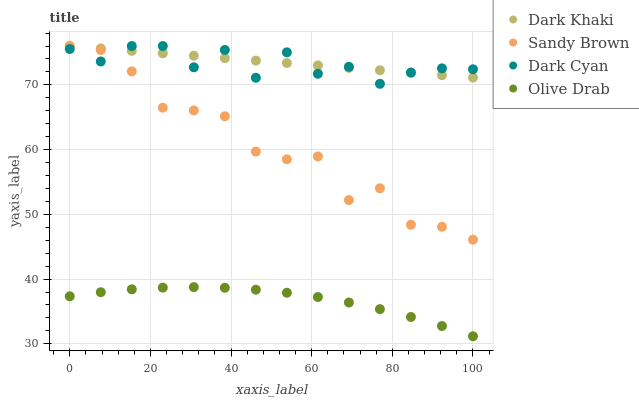Does Olive Drab have the minimum area under the curve?
Answer yes or no. Yes. Does Dark Khaki have the maximum area under the curve?
Answer yes or no. Yes. Does Dark Cyan have the minimum area under the curve?
Answer yes or no. No. Does Dark Cyan have the maximum area under the curve?
Answer yes or no. No. Is Dark Khaki the smoothest?
Answer yes or no. Yes. Is Dark Cyan the roughest?
Answer yes or no. Yes. Is Sandy Brown the smoothest?
Answer yes or no. No. Is Sandy Brown the roughest?
Answer yes or no. No. Does Olive Drab have the lowest value?
Answer yes or no. Yes. Does Dark Cyan have the lowest value?
Answer yes or no. No. Does Sandy Brown have the highest value?
Answer yes or no. Yes. Does Olive Drab have the highest value?
Answer yes or no. No. Is Olive Drab less than Dark Cyan?
Answer yes or no. Yes. Is Dark Cyan greater than Olive Drab?
Answer yes or no. Yes. Does Dark Cyan intersect Dark Khaki?
Answer yes or no. Yes. Is Dark Cyan less than Dark Khaki?
Answer yes or no. No. Is Dark Cyan greater than Dark Khaki?
Answer yes or no. No. Does Olive Drab intersect Dark Cyan?
Answer yes or no. No. 